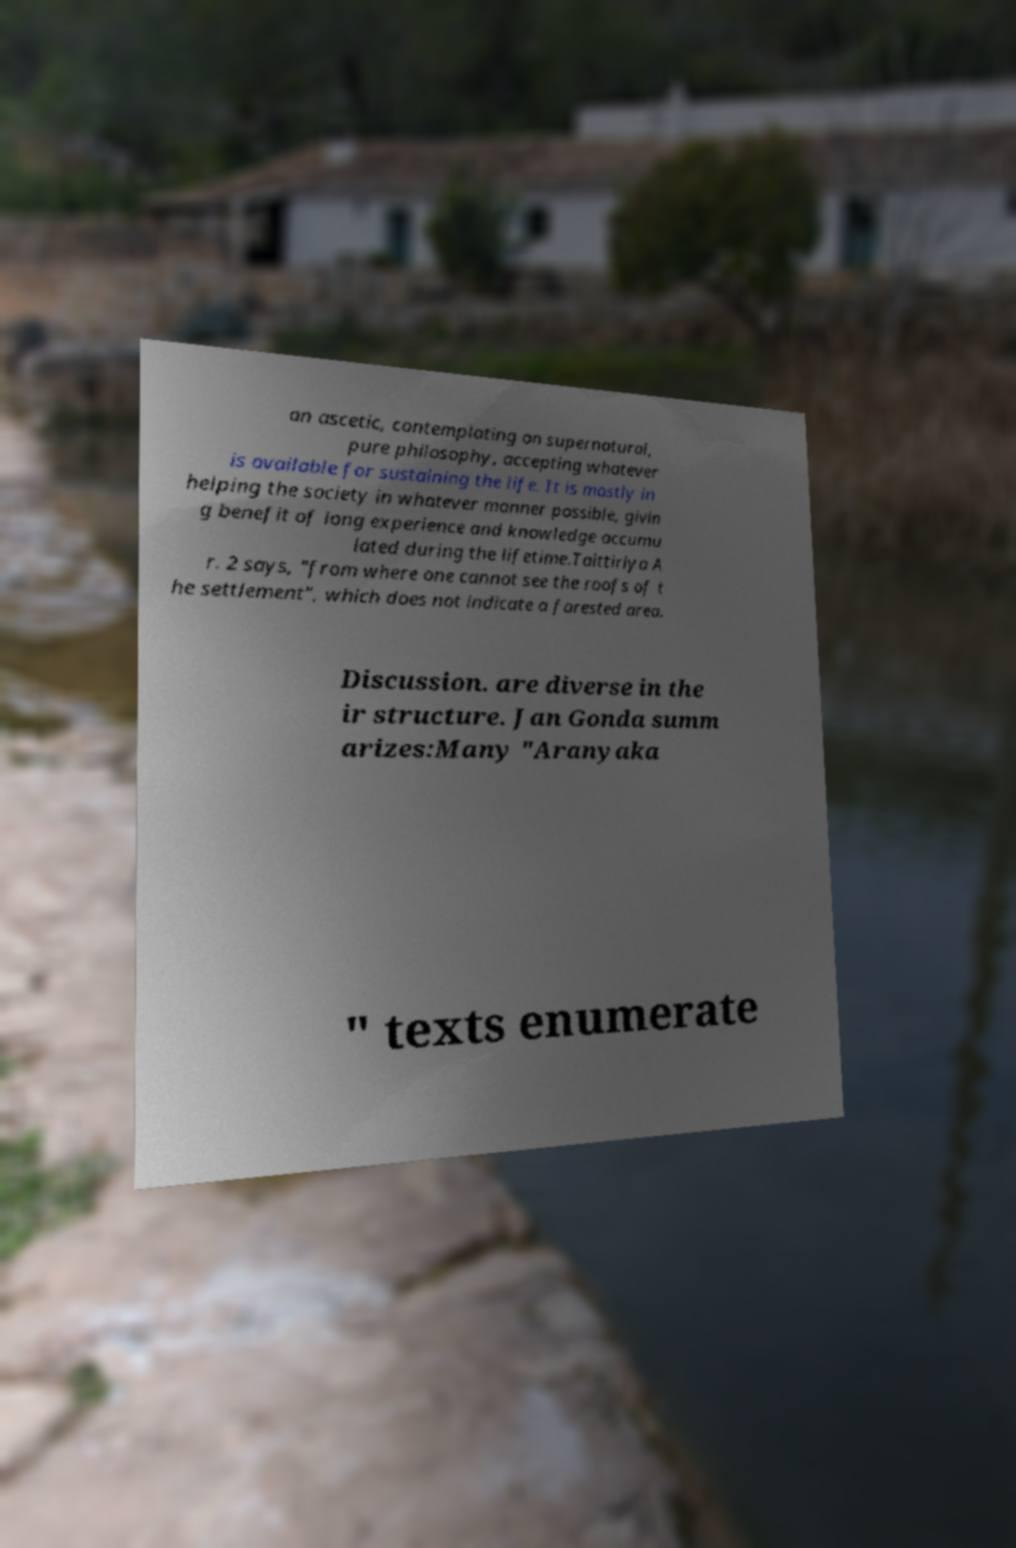Can you accurately transcribe the text from the provided image for me? an ascetic, contemplating on supernatural, pure philosophy, accepting whatever is available for sustaining the life. It is mostly in helping the society in whatever manner possible, givin g benefit of long experience and knowledge accumu lated during the lifetime.Taittiriya A r. 2 says, "from where one cannot see the roofs of t he settlement", which does not indicate a forested area. Discussion. are diverse in the ir structure. Jan Gonda summ arizes:Many "Aranyaka " texts enumerate 